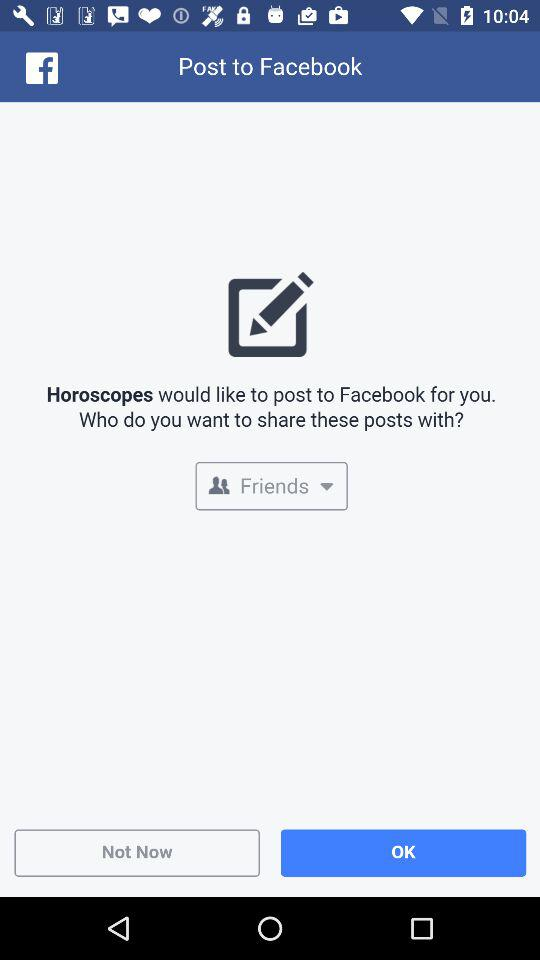What is the application name? The application names are "Horoscopes" and "Facebook". 